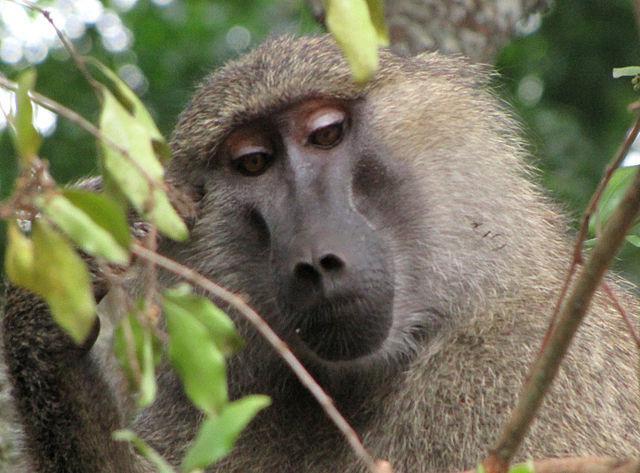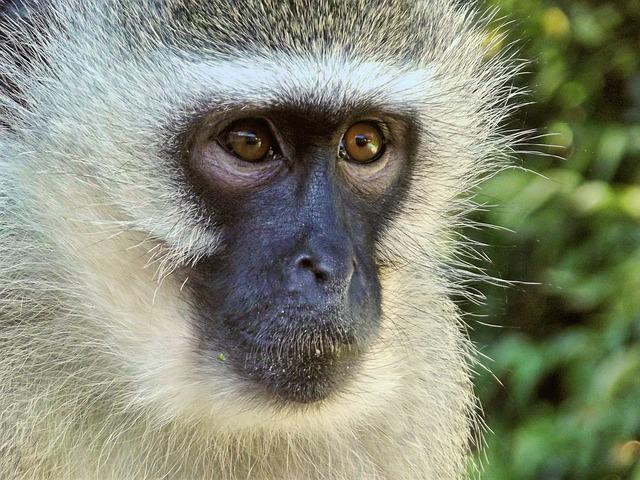The first image is the image on the left, the second image is the image on the right. Given the left and right images, does the statement "A baboon is standing on all fours with its tail and pink rear angled toward the camera and its head turned." hold true? Answer yes or no. No. The first image is the image on the left, the second image is the image on the right. For the images shown, is this caption "The left image contains exactly two baboons." true? Answer yes or no. No. 